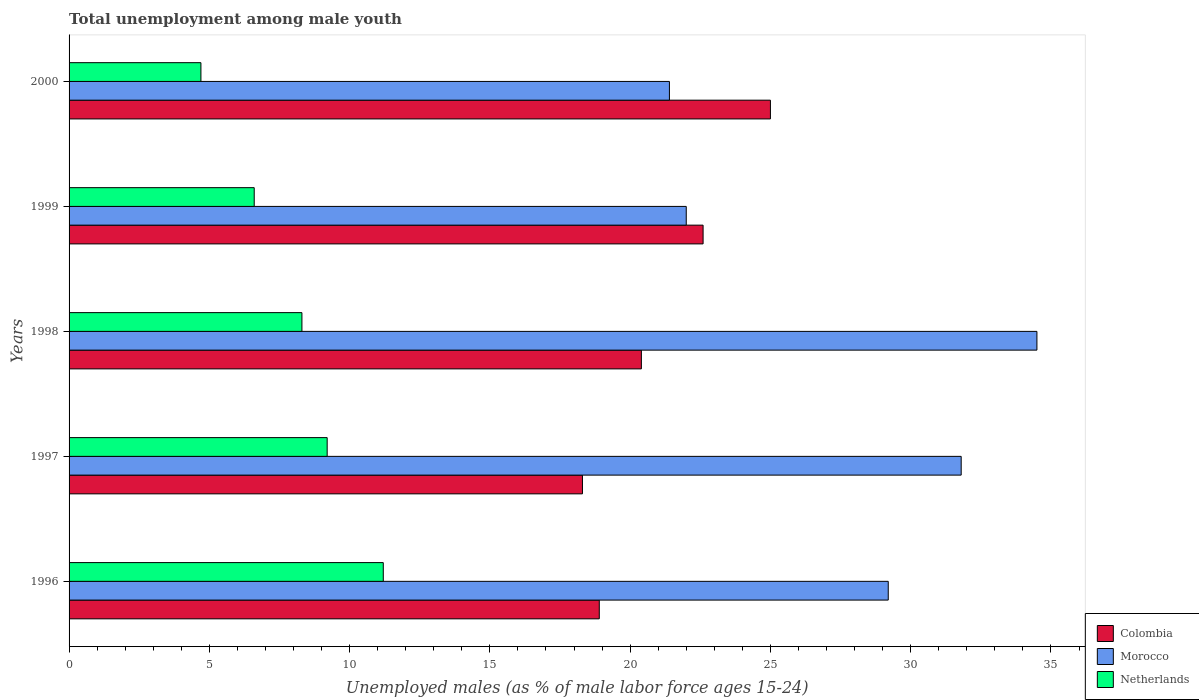Are the number of bars per tick equal to the number of legend labels?
Give a very brief answer. Yes. Are the number of bars on each tick of the Y-axis equal?
Provide a short and direct response. Yes. What is the label of the 5th group of bars from the top?
Keep it short and to the point. 1996. In how many cases, is the number of bars for a given year not equal to the number of legend labels?
Provide a succinct answer. 0. What is the percentage of unemployed males in in Colombia in 1996?
Your response must be concise. 18.9. Across all years, what is the maximum percentage of unemployed males in in Morocco?
Your response must be concise. 34.5. Across all years, what is the minimum percentage of unemployed males in in Netherlands?
Give a very brief answer. 4.7. In which year was the percentage of unemployed males in in Netherlands minimum?
Provide a short and direct response. 2000. What is the total percentage of unemployed males in in Colombia in the graph?
Keep it short and to the point. 105.2. What is the difference between the percentage of unemployed males in in Morocco in 1996 and that in 1999?
Provide a succinct answer. 7.2. What is the difference between the percentage of unemployed males in in Netherlands in 1996 and the percentage of unemployed males in in Colombia in 2000?
Your answer should be very brief. -13.8. What is the average percentage of unemployed males in in Morocco per year?
Your response must be concise. 27.78. In the year 1997, what is the difference between the percentage of unemployed males in in Morocco and percentage of unemployed males in in Netherlands?
Offer a very short reply. 22.6. In how many years, is the percentage of unemployed males in in Netherlands greater than 7 %?
Your response must be concise. 3. What is the ratio of the percentage of unemployed males in in Morocco in 1996 to that in 1997?
Your response must be concise. 0.92. What is the difference between the highest and the second highest percentage of unemployed males in in Netherlands?
Offer a terse response. 2. What is the difference between the highest and the lowest percentage of unemployed males in in Morocco?
Ensure brevity in your answer.  13.1. In how many years, is the percentage of unemployed males in in Morocco greater than the average percentage of unemployed males in in Morocco taken over all years?
Provide a succinct answer. 3. What does the 2nd bar from the top in 1999 represents?
Your answer should be very brief. Morocco. What does the 1st bar from the bottom in 1996 represents?
Keep it short and to the point. Colombia. How many bars are there?
Your answer should be compact. 15. Are the values on the major ticks of X-axis written in scientific E-notation?
Provide a short and direct response. No. How many legend labels are there?
Your answer should be compact. 3. What is the title of the graph?
Your response must be concise. Total unemployment among male youth. Does "European Union" appear as one of the legend labels in the graph?
Keep it short and to the point. No. What is the label or title of the X-axis?
Give a very brief answer. Unemployed males (as % of male labor force ages 15-24). What is the Unemployed males (as % of male labor force ages 15-24) of Colombia in 1996?
Make the answer very short. 18.9. What is the Unemployed males (as % of male labor force ages 15-24) of Morocco in 1996?
Provide a succinct answer. 29.2. What is the Unemployed males (as % of male labor force ages 15-24) of Netherlands in 1996?
Provide a succinct answer. 11.2. What is the Unemployed males (as % of male labor force ages 15-24) of Colombia in 1997?
Ensure brevity in your answer.  18.3. What is the Unemployed males (as % of male labor force ages 15-24) of Morocco in 1997?
Offer a very short reply. 31.8. What is the Unemployed males (as % of male labor force ages 15-24) of Netherlands in 1997?
Your answer should be compact. 9.2. What is the Unemployed males (as % of male labor force ages 15-24) in Colombia in 1998?
Ensure brevity in your answer.  20.4. What is the Unemployed males (as % of male labor force ages 15-24) in Morocco in 1998?
Your response must be concise. 34.5. What is the Unemployed males (as % of male labor force ages 15-24) of Netherlands in 1998?
Offer a terse response. 8.3. What is the Unemployed males (as % of male labor force ages 15-24) in Colombia in 1999?
Your answer should be compact. 22.6. What is the Unemployed males (as % of male labor force ages 15-24) of Morocco in 1999?
Your answer should be compact. 22. What is the Unemployed males (as % of male labor force ages 15-24) of Netherlands in 1999?
Provide a short and direct response. 6.6. What is the Unemployed males (as % of male labor force ages 15-24) in Colombia in 2000?
Make the answer very short. 25. What is the Unemployed males (as % of male labor force ages 15-24) in Morocco in 2000?
Give a very brief answer. 21.4. What is the Unemployed males (as % of male labor force ages 15-24) of Netherlands in 2000?
Ensure brevity in your answer.  4.7. Across all years, what is the maximum Unemployed males (as % of male labor force ages 15-24) of Morocco?
Your answer should be compact. 34.5. Across all years, what is the maximum Unemployed males (as % of male labor force ages 15-24) in Netherlands?
Provide a short and direct response. 11.2. Across all years, what is the minimum Unemployed males (as % of male labor force ages 15-24) of Colombia?
Keep it short and to the point. 18.3. Across all years, what is the minimum Unemployed males (as % of male labor force ages 15-24) in Morocco?
Make the answer very short. 21.4. Across all years, what is the minimum Unemployed males (as % of male labor force ages 15-24) in Netherlands?
Give a very brief answer. 4.7. What is the total Unemployed males (as % of male labor force ages 15-24) of Colombia in the graph?
Give a very brief answer. 105.2. What is the total Unemployed males (as % of male labor force ages 15-24) in Morocco in the graph?
Your answer should be compact. 138.9. What is the total Unemployed males (as % of male labor force ages 15-24) in Netherlands in the graph?
Your answer should be very brief. 40. What is the difference between the Unemployed males (as % of male labor force ages 15-24) of Colombia in 1996 and that in 1997?
Your answer should be very brief. 0.6. What is the difference between the Unemployed males (as % of male labor force ages 15-24) in Netherlands in 1996 and that in 1997?
Keep it short and to the point. 2. What is the difference between the Unemployed males (as % of male labor force ages 15-24) of Colombia in 1996 and that in 1998?
Provide a short and direct response. -1.5. What is the difference between the Unemployed males (as % of male labor force ages 15-24) of Morocco in 1996 and that in 1998?
Provide a short and direct response. -5.3. What is the difference between the Unemployed males (as % of male labor force ages 15-24) of Netherlands in 1996 and that in 1999?
Keep it short and to the point. 4.6. What is the difference between the Unemployed males (as % of male labor force ages 15-24) in Colombia in 1996 and that in 2000?
Give a very brief answer. -6.1. What is the difference between the Unemployed males (as % of male labor force ages 15-24) in Netherlands in 1996 and that in 2000?
Your response must be concise. 6.5. What is the difference between the Unemployed males (as % of male labor force ages 15-24) in Colombia in 1997 and that in 1998?
Provide a succinct answer. -2.1. What is the difference between the Unemployed males (as % of male labor force ages 15-24) of Morocco in 1997 and that in 1998?
Your answer should be compact. -2.7. What is the difference between the Unemployed males (as % of male labor force ages 15-24) of Morocco in 1997 and that in 1999?
Your answer should be very brief. 9.8. What is the difference between the Unemployed males (as % of male labor force ages 15-24) of Netherlands in 1997 and that in 1999?
Keep it short and to the point. 2.6. What is the difference between the Unemployed males (as % of male labor force ages 15-24) of Colombia in 1997 and that in 2000?
Ensure brevity in your answer.  -6.7. What is the difference between the Unemployed males (as % of male labor force ages 15-24) of Netherlands in 1997 and that in 2000?
Ensure brevity in your answer.  4.5. What is the difference between the Unemployed males (as % of male labor force ages 15-24) in Colombia in 1998 and that in 2000?
Ensure brevity in your answer.  -4.6. What is the difference between the Unemployed males (as % of male labor force ages 15-24) of Netherlands in 1998 and that in 2000?
Provide a short and direct response. 3.6. What is the difference between the Unemployed males (as % of male labor force ages 15-24) in Morocco in 1999 and that in 2000?
Offer a terse response. 0.6. What is the difference between the Unemployed males (as % of male labor force ages 15-24) of Netherlands in 1999 and that in 2000?
Make the answer very short. 1.9. What is the difference between the Unemployed males (as % of male labor force ages 15-24) in Colombia in 1996 and the Unemployed males (as % of male labor force ages 15-24) in Morocco in 1997?
Your response must be concise. -12.9. What is the difference between the Unemployed males (as % of male labor force ages 15-24) of Colombia in 1996 and the Unemployed males (as % of male labor force ages 15-24) of Netherlands in 1997?
Keep it short and to the point. 9.7. What is the difference between the Unemployed males (as % of male labor force ages 15-24) of Morocco in 1996 and the Unemployed males (as % of male labor force ages 15-24) of Netherlands in 1997?
Your answer should be very brief. 20. What is the difference between the Unemployed males (as % of male labor force ages 15-24) of Colombia in 1996 and the Unemployed males (as % of male labor force ages 15-24) of Morocco in 1998?
Make the answer very short. -15.6. What is the difference between the Unemployed males (as % of male labor force ages 15-24) of Morocco in 1996 and the Unemployed males (as % of male labor force ages 15-24) of Netherlands in 1998?
Ensure brevity in your answer.  20.9. What is the difference between the Unemployed males (as % of male labor force ages 15-24) in Colombia in 1996 and the Unemployed males (as % of male labor force ages 15-24) in Morocco in 1999?
Your response must be concise. -3.1. What is the difference between the Unemployed males (as % of male labor force ages 15-24) of Morocco in 1996 and the Unemployed males (as % of male labor force ages 15-24) of Netherlands in 1999?
Offer a terse response. 22.6. What is the difference between the Unemployed males (as % of male labor force ages 15-24) in Morocco in 1996 and the Unemployed males (as % of male labor force ages 15-24) in Netherlands in 2000?
Your response must be concise. 24.5. What is the difference between the Unemployed males (as % of male labor force ages 15-24) of Colombia in 1997 and the Unemployed males (as % of male labor force ages 15-24) of Morocco in 1998?
Your answer should be compact. -16.2. What is the difference between the Unemployed males (as % of male labor force ages 15-24) of Colombia in 1997 and the Unemployed males (as % of male labor force ages 15-24) of Netherlands in 1998?
Your answer should be compact. 10. What is the difference between the Unemployed males (as % of male labor force ages 15-24) of Morocco in 1997 and the Unemployed males (as % of male labor force ages 15-24) of Netherlands in 1998?
Give a very brief answer. 23.5. What is the difference between the Unemployed males (as % of male labor force ages 15-24) in Morocco in 1997 and the Unemployed males (as % of male labor force ages 15-24) in Netherlands in 1999?
Make the answer very short. 25.2. What is the difference between the Unemployed males (as % of male labor force ages 15-24) of Colombia in 1997 and the Unemployed males (as % of male labor force ages 15-24) of Morocco in 2000?
Offer a very short reply. -3.1. What is the difference between the Unemployed males (as % of male labor force ages 15-24) in Morocco in 1997 and the Unemployed males (as % of male labor force ages 15-24) in Netherlands in 2000?
Provide a succinct answer. 27.1. What is the difference between the Unemployed males (as % of male labor force ages 15-24) of Morocco in 1998 and the Unemployed males (as % of male labor force ages 15-24) of Netherlands in 1999?
Provide a short and direct response. 27.9. What is the difference between the Unemployed males (as % of male labor force ages 15-24) of Colombia in 1998 and the Unemployed males (as % of male labor force ages 15-24) of Morocco in 2000?
Keep it short and to the point. -1. What is the difference between the Unemployed males (as % of male labor force ages 15-24) of Colombia in 1998 and the Unemployed males (as % of male labor force ages 15-24) of Netherlands in 2000?
Ensure brevity in your answer.  15.7. What is the difference between the Unemployed males (as % of male labor force ages 15-24) of Morocco in 1998 and the Unemployed males (as % of male labor force ages 15-24) of Netherlands in 2000?
Offer a terse response. 29.8. What is the difference between the Unemployed males (as % of male labor force ages 15-24) in Colombia in 1999 and the Unemployed males (as % of male labor force ages 15-24) in Morocco in 2000?
Give a very brief answer. 1.2. What is the average Unemployed males (as % of male labor force ages 15-24) of Colombia per year?
Make the answer very short. 21.04. What is the average Unemployed males (as % of male labor force ages 15-24) of Morocco per year?
Ensure brevity in your answer.  27.78. In the year 1996, what is the difference between the Unemployed males (as % of male labor force ages 15-24) of Colombia and Unemployed males (as % of male labor force ages 15-24) of Morocco?
Provide a succinct answer. -10.3. In the year 1997, what is the difference between the Unemployed males (as % of male labor force ages 15-24) in Morocco and Unemployed males (as % of male labor force ages 15-24) in Netherlands?
Ensure brevity in your answer.  22.6. In the year 1998, what is the difference between the Unemployed males (as % of male labor force ages 15-24) in Colombia and Unemployed males (as % of male labor force ages 15-24) in Morocco?
Offer a terse response. -14.1. In the year 1998, what is the difference between the Unemployed males (as % of male labor force ages 15-24) of Morocco and Unemployed males (as % of male labor force ages 15-24) of Netherlands?
Give a very brief answer. 26.2. In the year 2000, what is the difference between the Unemployed males (as % of male labor force ages 15-24) of Colombia and Unemployed males (as % of male labor force ages 15-24) of Netherlands?
Ensure brevity in your answer.  20.3. In the year 2000, what is the difference between the Unemployed males (as % of male labor force ages 15-24) in Morocco and Unemployed males (as % of male labor force ages 15-24) in Netherlands?
Ensure brevity in your answer.  16.7. What is the ratio of the Unemployed males (as % of male labor force ages 15-24) in Colombia in 1996 to that in 1997?
Give a very brief answer. 1.03. What is the ratio of the Unemployed males (as % of male labor force ages 15-24) of Morocco in 1996 to that in 1997?
Offer a terse response. 0.92. What is the ratio of the Unemployed males (as % of male labor force ages 15-24) in Netherlands in 1996 to that in 1997?
Make the answer very short. 1.22. What is the ratio of the Unemployed males (as % of male labor force ages 15-24) in Colombia in 1996 to that in 1998?
Offer a very short reply. 0.93. What is the ratio of the Unemployed males (as % of male labor force ages 15-24) of Morocco in 1996 to that in 1998?
Your response must be concise. 0.85. What is the ratio of the Unemployed males (as % of male labor force ages 15-24) in Netherlands in 1996 to that in 1998?
Give a very brief answer. 1.35. What is the ratio of the Unemployed males (as % of male labor force ages 15-24) of Colombia in 1996 to that in 1999?
Provide a short and direct response. 0.84. What is the ratio of the Unemployed males (as % of male labor force ages 15-24) in Morocco in 1996 to that in 1999?
Provide a succinct answer. 1.33. What is the ratio of the Unemployed males (as % of male labor force ages 15-24) of Netherlands in 1996 to that in 1999?
Offer a terse response. 1.7. What is the ratio of the Unemployed males (as % of male labor force ages 15-24) of Colombia in 1996 to that in 2000?
Offer a terse response. 0.76. What is the ratio of the Unemployed males (as % of male labor force ages 15-24) in Morocco in 1996 to that in 2000?
Offer a terse response. 1.36. What is the ratio of the Unemployed males (as % of male labor force ages 15-24) in Netherlands in 1996 to that in 2000?
Your answer should be very brief. 2.38. What is the ratio of the Unemployed males (as % of male labor force ages 15-24) of Colombia in 1997 to that in 1998?
Your answer should be compact. 0.9. What is the ratio of the Unemployed males (as % of male labor force ages 15-24) in Morocco in 1997 to that in 1998?
Make the answer very short. 0.92. What is the ratio of the Unemployed males (as % of male labor force ages 15-24) in Netherlands in 1997 to that in 1998?
Offer a terse response. 1.11. What is the ratio of the Unemployed males (as % of male labor force ages 15-24) in Colombia in 1997 to that in 1999?
Keep it short and to the point. 0.81. What is the ratio of the Unemployed males (as % of male labor force ages 15-24) in Morocco in 1997 to that in 1999?
Your answer should be very brief. 1.45. What is the ratio of the Unemployed males (as % of male labor force ages 15-24) in Netherlands in 1997 to that in 1999?
Your answer should be very brief. 1.39. What is the ratio of the Unemployed males (as % of male labor force ages 15-24) of Colombia in 1997 to that in 2000?
Keep it short and to the point. 0.73. What is the ratio of the Unemployed males (as % of male labor force ages 15-24) in Morocco in 1997 to that in 2000?
Provide a short and direct response. 1.49. What is the ratio of the Unemployed males (as % of male labor force ages 15-24) of Netherlands in 1997 to that in 2000?
Make the answer very short. 1.96. What is the ratio of the Unemployed males (as % of male labor force ages 15-24) of Colombia in 1998 to that in 1999?
Your answer should be very brief. 0.9. What is the ratio of the Unemployed males (as % of male labor force ages 15-24) in Morocco in 1998 to that in 1999?
Make the answer very short. 1.57. What is the ratio of the Unemployed males (as % of male labor force ages 15-24) in Netherlands in 1998 to that in 1999?
Keep it short and to the point. 1.26. What is the ratio of the Unemployed males (as % of male labor force ages 15-24) in Colombia in 1998 to that in 2000?
Your answer should be compact. 0.82. What is the ratio of the Unemployed males (as % of male labor force ages 15-24) in Morocco in 1998 to that in 2000?
Keep it short and to the point. 1.61. What is the ratio of the Unemployed males (as % of male labor force ages 15-24) of Netherlands in 1998 to that in 2000?
Offer a very short reply. 1.77. What is the ratio of the Unemployed males (as % of male labor force ages 15-24) of Colombia in 1999 to that in 2000?
Your answer should be compact. 0.9. What is the ratio of the Unemployed males (as % of male labor force ages 15-24) of Morocco in 1999 to that in 2000?
Provide a short and direct response. 1.03. What is the ratio of the Unemployed males (as % of male labor force ages 15-24) in Netherlands in 1999 to that in 2000?
Keep it short and to the point. 1.4. What is the difference between the highest and the lowest Unemployed males (as % of male labor force ages 15-24) of Morocco?
Give a very brief answer. 13.1. What is the difference between the highest and the lowest Unemployed males (as % of male labor force ages 15-24) of Netherlands?
Offer a terse response. 6.5. 